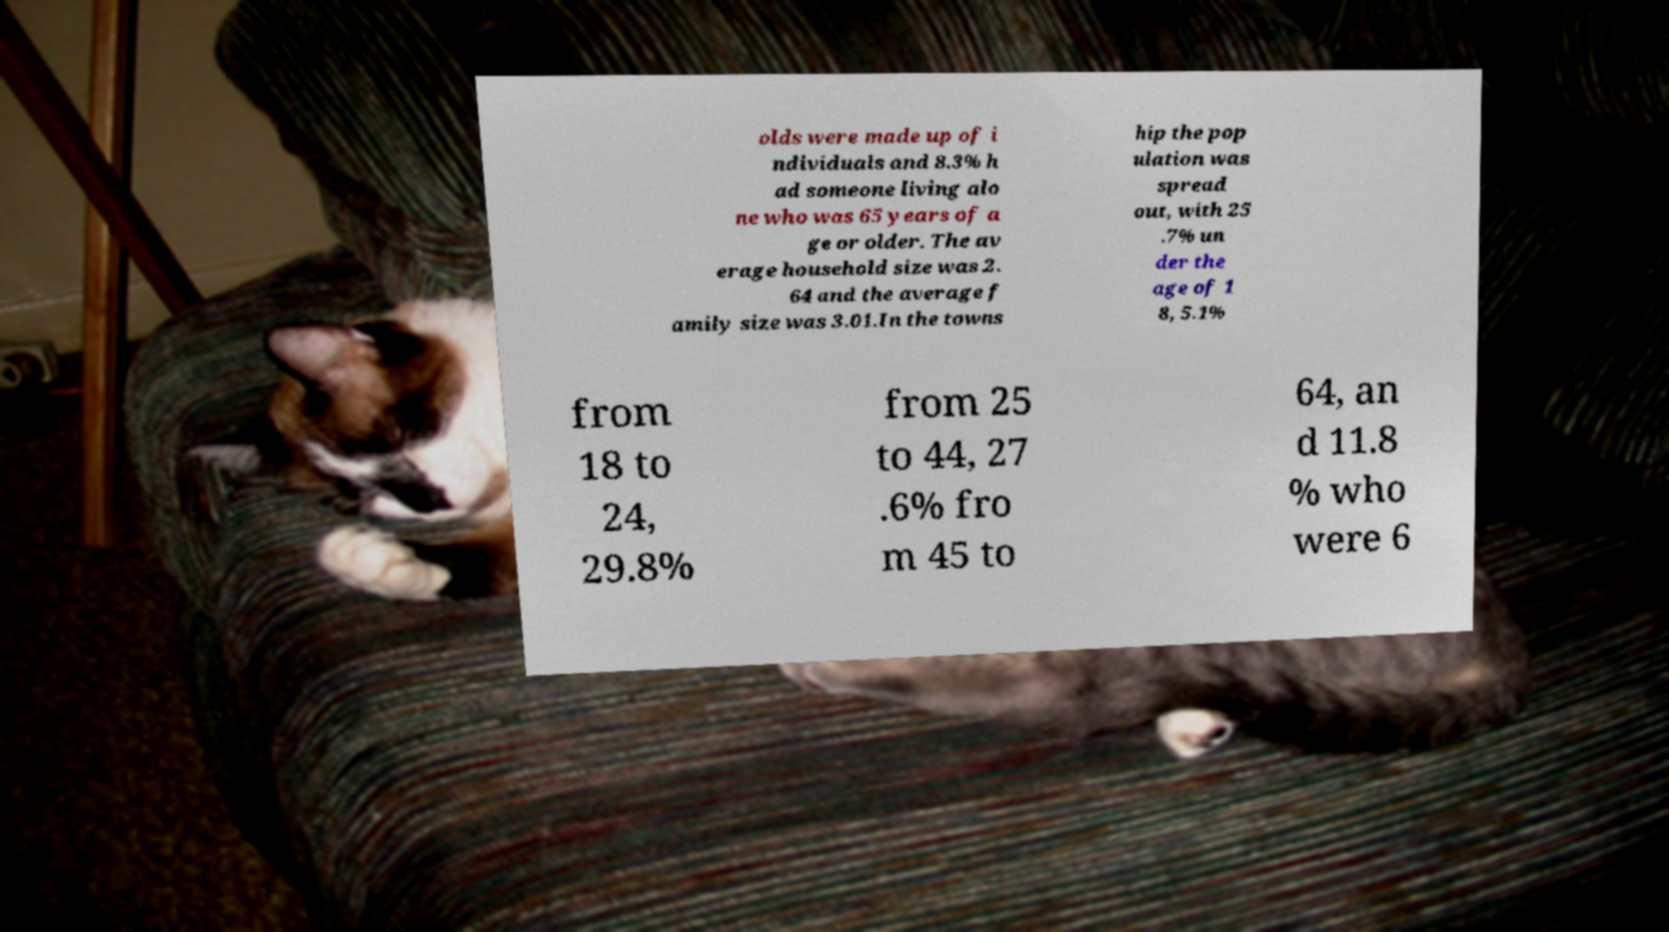What messages or text are displayed in this image? I need them in a readable, typed format. olds were made up of i ndividuals and 8.3% h ad someone living alo ne who was 65 years of a ge or older. The av erage household size was 2. 64 and the average f amily size was 3.01.In the towns hip the pop ulation was spread out, with 25 .7% un der the age of 1 8, 5.1% from 18 to 24, 29.8% from 25 to 44, 27 .6% fro m 45 to 64, an d 11.8 % who were 6 